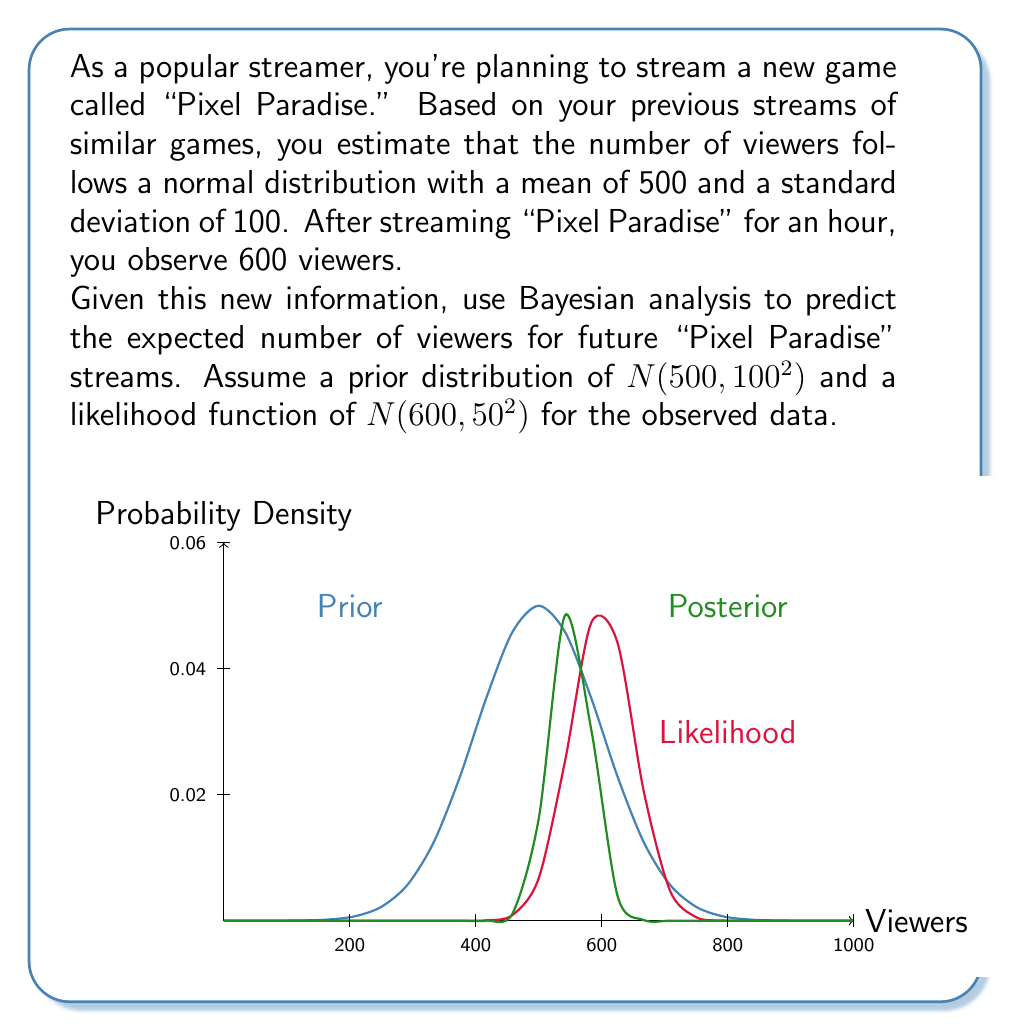What is the answer to this math problem? Let's approach this step-by-step using Bayesian analysis:

1) We start with a prior distribution: $N(\mu_0 = 500, \sigma_0^2 = 100^2)$
2) Our likelihood function based on the new data is: $N(\mu_1 = 600, \sigma_1^2 = 50^2)$

3) In Bayesian analysis, the posterior distribution is also normal when both prior and likelihood are normal. The posterior parameters are given by:

   $$\mu_{posterior} = \frac{\frac{\mu_0}{\sigma_0^2} + \frac{\mu_1}{\sigma_1^2}}{\frac{1}{\sigma_0^2} + \frac{1}{\sigma_1^2}}$$

   $$\frac{1}{\sigma_{posterior}^2} = \frac{1}{\sigma_0^2} + \frac{1}{\sigma_1^2}$$

4) Let's calculate $\sigma_{posterior}^2$ first:
   
   $$\frac{1}{\sigma_{posterior}^2} = \frac{1}{100^2} + \frac{1}{50^2} = 0.0001 + 0.0004 = 0.0005$$
   
   $$\sigma_{posterior}^2 = \frac{1}{0.0005} = 2000$$
   
   $$\sigma_{posterior} \approx 44.72$$

5) Now for $\mu_{posterior}$:

   $$\mu_{posterior} = \frac{\frac{500}{100^2} + \frac{600}{50^2}}{0.0005} = \frac{0.05 + 0.24}{0.0005} = \frac{0.29}{0.0005} = 580$$

6) Therefore, our posterior distribution is $N(580, 44.72^2)$

7) The expected number of viewers for future streams is the mean of this posterior distribution: 580
Answer: 580 viewers 